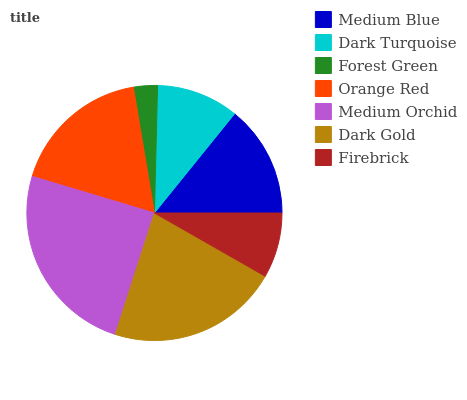Is Forest Green the minimum?
Answer yes or no. Yes. Is Medium Orchid the maximum?
Answer yes or no. Yes. Is Dark Turquoise the minimum?
Answer yes or no. No. Is Dark Turquoise the maximum?
Answer yes or no. No. Is Medium Blue greater than Dark Turquoise?
Answer yes or no. Yes. Is Dark Turquoise less than Medium Blue?
Answer yes or no. Yes. Is Dark Turquoise greater than Medium Blue?
Answer yes or no. No. Is Medium Blue less than Dark Turquoise?
Answer yes or no. No. Is Medium Blue the high median?
Answer yes or no. Yes. Is Medium Blue the low median?
Answer yes or no. Yes. Is Medium Orchid the high median?
Answer yes or no. No. Is Orange Red the low median?
Answer yes or no. No. 